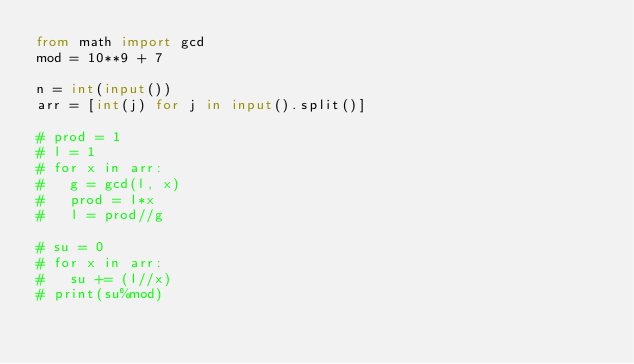<code> <loc_0><loc_0><loc_500><loc_500><_Python_>from math import gcd
mod = 10**9 + 7

n = int(input())
arr = [int(j) for j in input().split()]

# prod = 1
# l = 1
# for x in arr:
# 	g = gcd(l, x)
# 	prod = l*x
# 	l = prod//g

# su = 0
# for x in arr:
# 	su += (l//x)
# print(su%mod)
</code> 